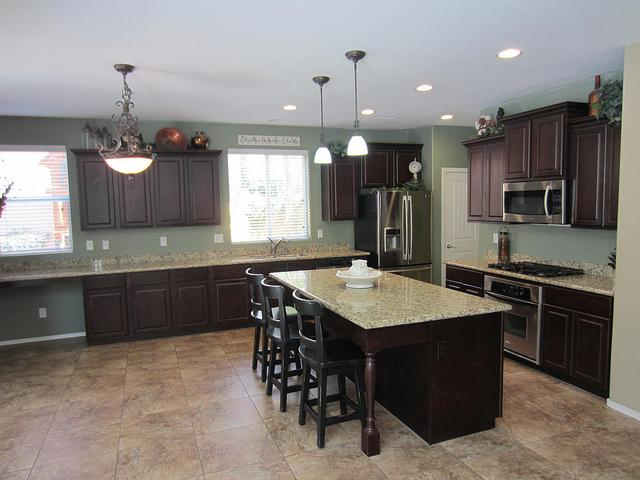What is the right side of the room mainly used for? cooking 